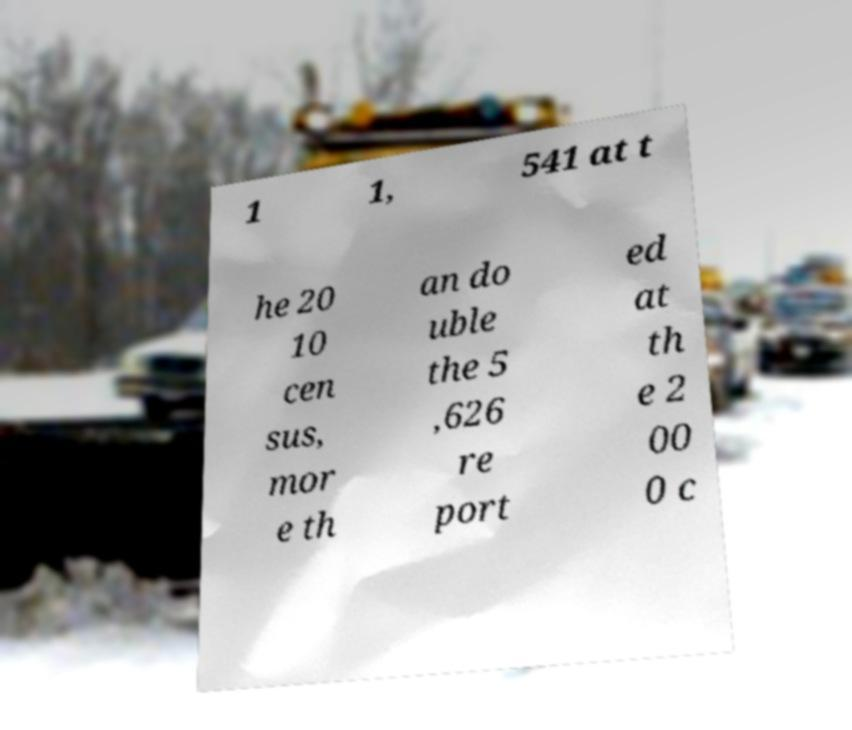Can you read and provide the text displayed in the image?This photo seems to have some interesting text. Can you extract and type it out for me? 1 1, 541 at t he 20 10 cen sus, mor e th an do uble the 5 ,626 re port ed at th e 2 00 0 c 